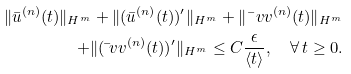Convert formula to latex. <formula><loc_0><loc_0><loc_500><loc_500>\| \bar { u } ^ { ( n ) } ( t ) \| _ { H ^ { m } } + \| ( \bar { u } ^ { ( n ) } ( t ) ) ^ { \prime } \| _ { H ^ { m } } + \| \bar { \ } v v ^ { ( n ) } ( t ) \| _ { H ^ { m } } \\ + \| ( \bar { \ } v v ^ { ( n ) } ( t ) ) ^ { \prime } \| _ { H ^ { m } } \leq C \frac { \epsilon } { \langle t \rangle } , \quad \forall \, t \geq 0 .</formula> 